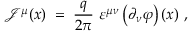<formula> <loc_0><loc_0><loc_500><loc_500>{ \mathcal { J } } ^ { \mu } ( x ) \, = \, \frac { q } { 2 \pi } \varepsilon ^ { \mu \nu } \left ( \partial _ { \nu } \varphi \right ) ( x ) ,</formula> 